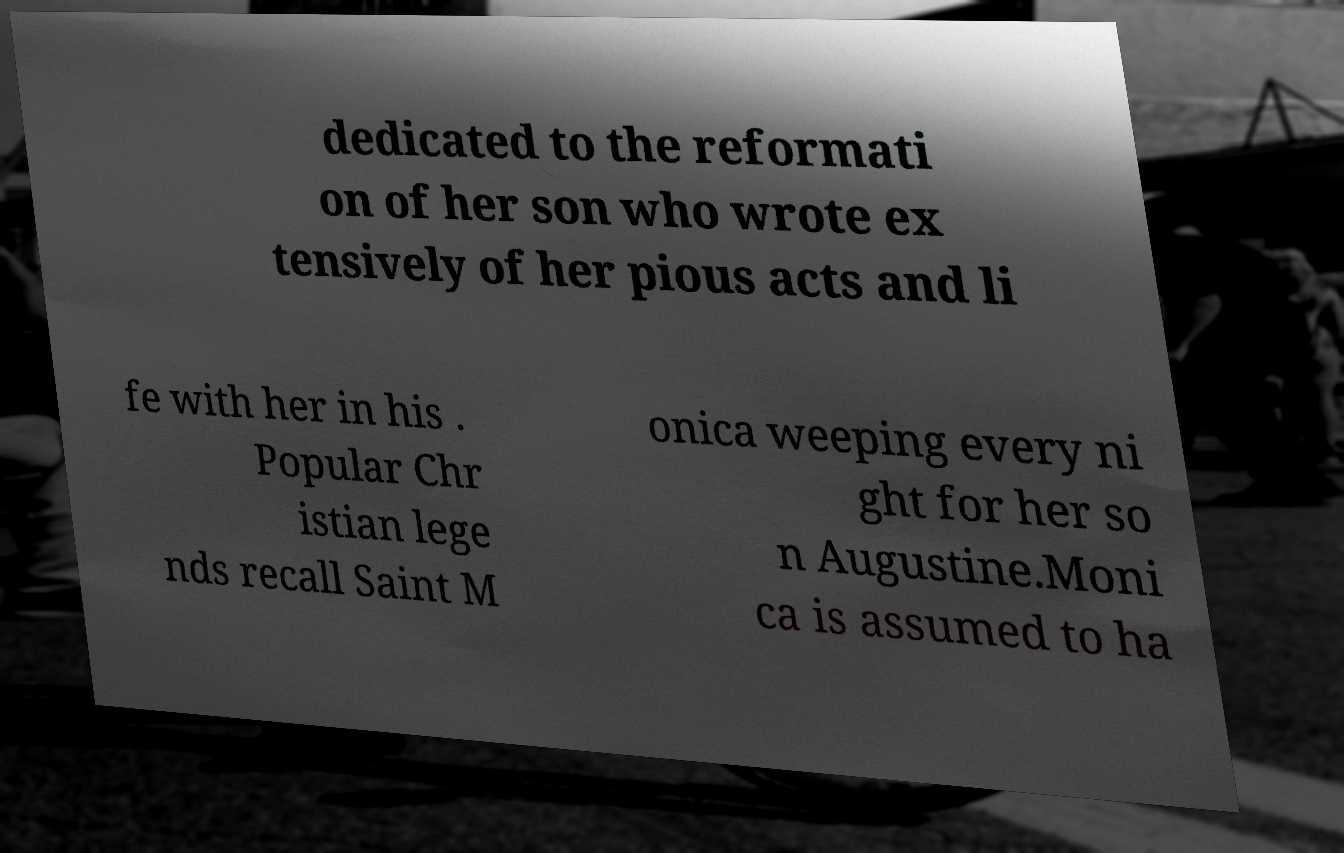I need the written content from this picture converted into text. Can you do that? dedicated to the reformati on of her son who wrote ex tensively of her pious acts and li fe with her in his . Popular Chr istian lege nds recall Saint M onica weeping every ni ght for her so n Augustine.Moni ca is assumed to ha 